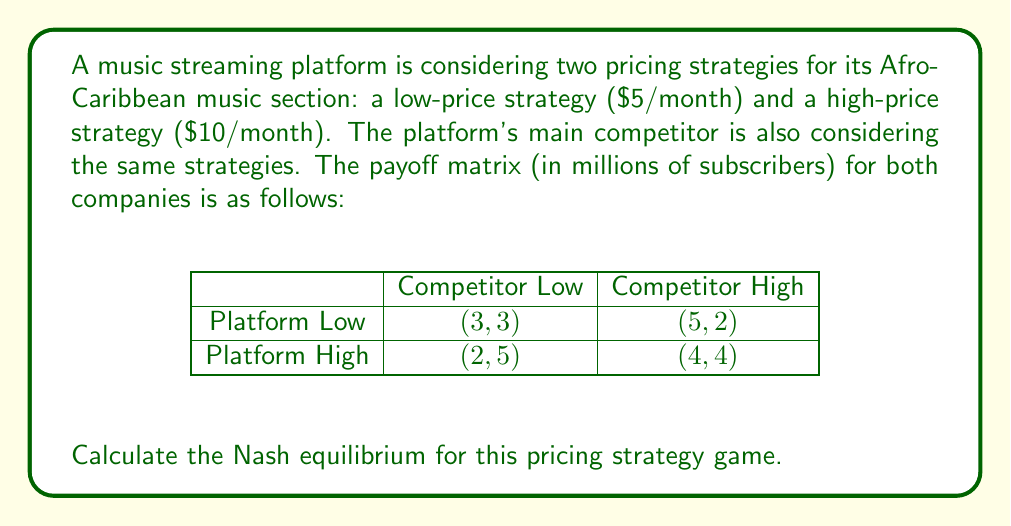Show me your answer to this math problem. To find the Nash equilibrium, we need to determine if there's a set of strategies where neither player has an incentive to unilaterally change their strategy.

1. First, let's check if there's a pure strategy Nash equilibrium:

   a) If the competitor chooses Low:
      - Platform's best response is Low (3 > 2)
   b) If the competitor chooses High:
      - Platform's best response is Low (5 > 4)
   c) If the platform chooses Low:
      - Competitor's best response is Low (3 > 2)
   d) If the platform chooses High:
      - Competitor's best response is Low (5 > 4)

   There's no pure strategy Nash equilibrium because there's no cell where both players are playing their best responses simultaneously.

2. Now, let's solve for a mixed strategy Nash equilibrium:

   Let $p$ be the probability that the platform chooses Low, and $q$ be the probability that the competitor chooses Low.

3. For the platform to be indifferent between Low and High:

   $3q + 5(1-q) = 2q + 4(1-q)$
   $3q + 5 - 5q = 2q + 4 - 4q$
   $-2q + 5 = -2q + 4$
   $5 = 4$
   $q = \frac{1}{2}$

4. For the competitor to be indifferent between Low and High:

   $3p + 2(1-p) = 5p + 4(1-p)$
   $3p + 2 - 2p = 5p + 4 - 4p$
   $p + 2 = p + 4$
   $p = \frac{2}{3}$

5. Therefore, the mixed strategy Nash equilibrium is:
   - Platform chooses Low with probability $\frac{2}{3}$ and High with probability $\frac{1}{3}$
   - Competitor chooses Low with probability $\frac{1}{2}$ and High with probability $\frac{1}{2}$

6. The expected payoff for each player in this equilibrium is:

   For the platform: $3 \cdot \frac{2}{3} \cdot \frac{1}{2} + 5 \cdot \frac{2}{3} \cdot \frac{1}{2} + 2 \cdot \frac{1}{3} \cdot \frac{1}{2} + 4 \cdot \frac{1}{3} \cdot \frac{1}{2} = \frac{10}{3}$ million subscribers

   For the competitor: $3 \cdot \frac{1}{2} \cdot \frac{2}{3} + 2 \cdot \frac{1}{2} \cdot \frac{2}{3} + 5 \cdot \frac{1}{2} \cdot \frac{1}{3} + 4 \cdot \frac{1}{2} \cdot \frac{1}{3} = \frac{10}{3}$ million subscribers
Answer: The Nash equilibrium is a mixed strategy where the platform chooses Low with probability $\frac{2}{3}$ and High with probability $\frac{1}{3}$, while the competitor chooses Low with probability $\frac{1}{2}$ and High with probability $\frac{1}{2}$. The expected payoff for each player is $\frac{10}{3}$ million subscribers. 